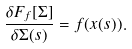Convert formula to latex. <formula><loc_0><loc_0><loc_500><loc_500>\frac { \delta F _ { f } [ \Sigma ] } { \delta \Sigma ( s ) } = f ( x ( s ) ) .</formula> 